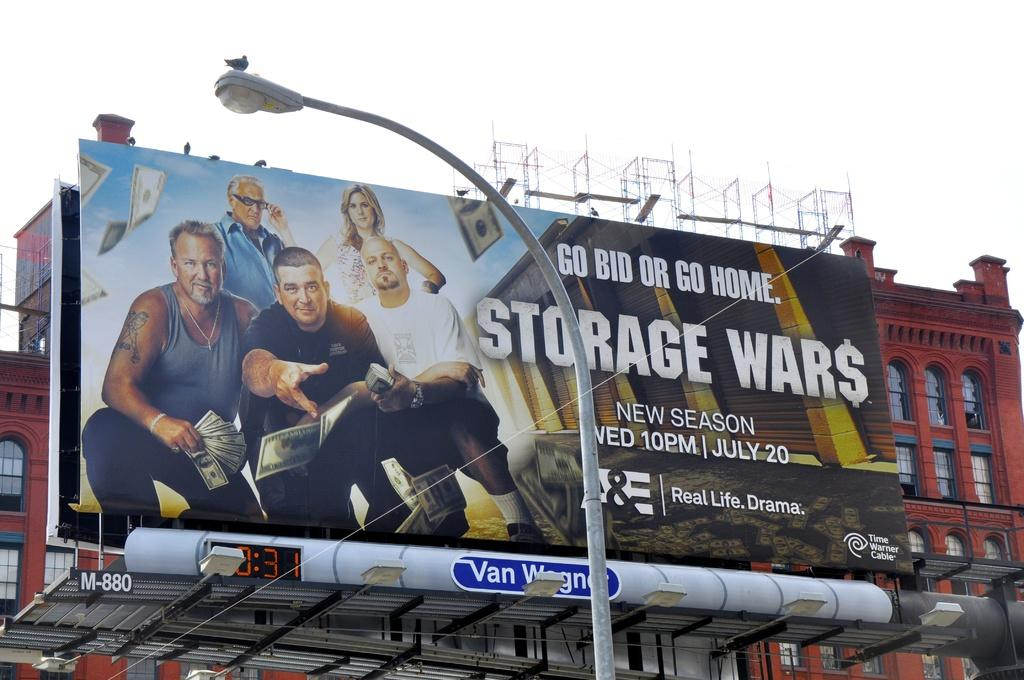<image>
Give a short and clear explanation of the subsequent image. A large billboard advertises the show Storage Wars. 